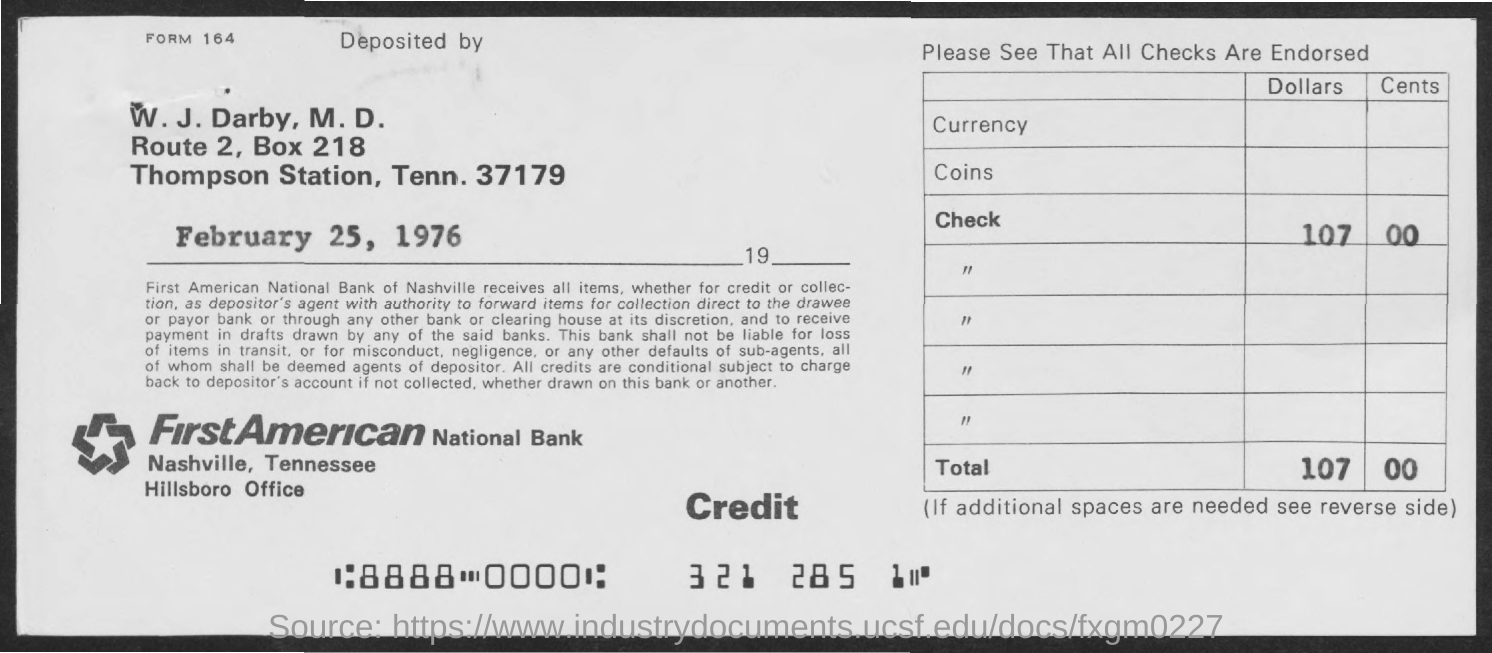Specify some key components in this picture. The station mentioned is Thompson Station. There is a check mentioned in the amount of 107,000 dollars. First American National Bank is the name of the bank mentioned. The telephone number mentioned is 37179. The box number mentioned is 218. 